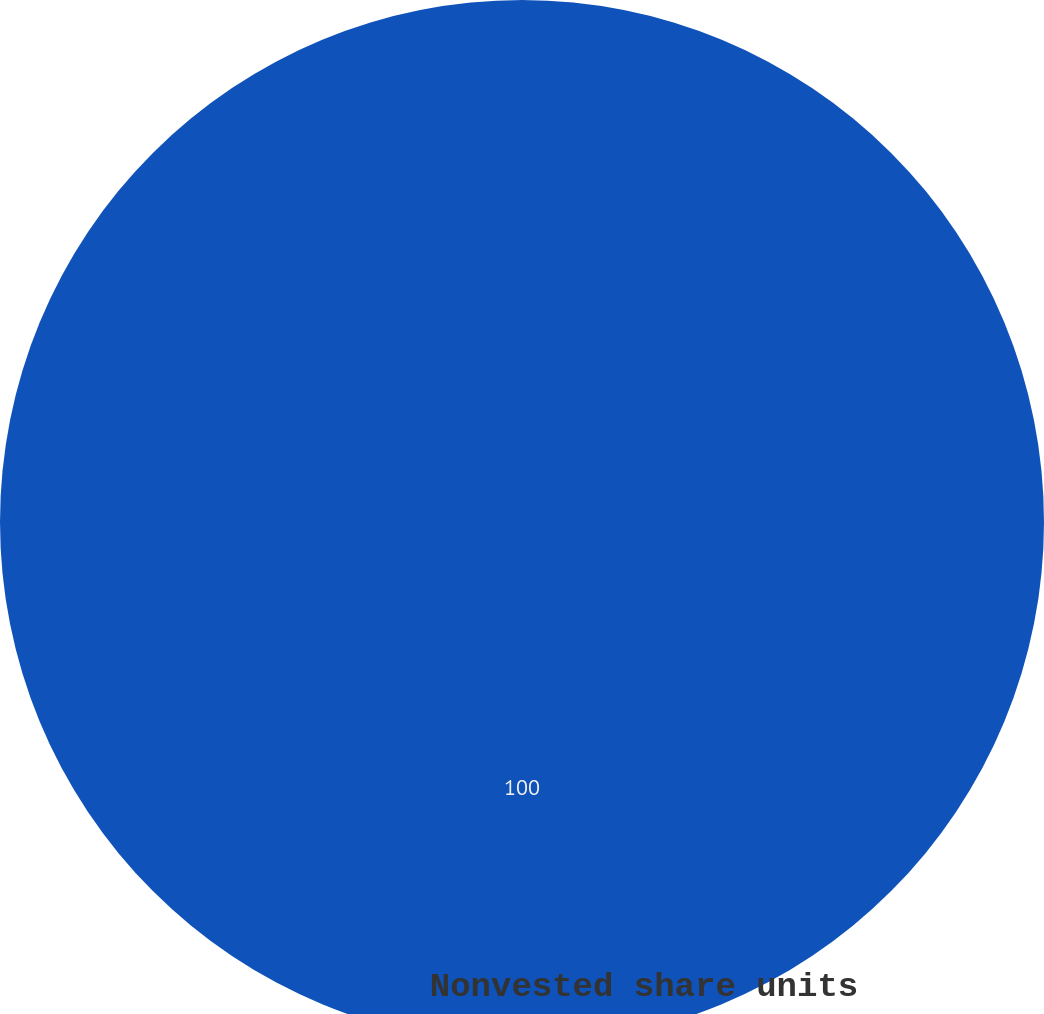Convert chart to OTSL. <chart><loc_0><loc_0><loc_500><loc_500><pie_chart><fcel>Nonvested share units<nl><fcel>100.0%<nl></chart> 